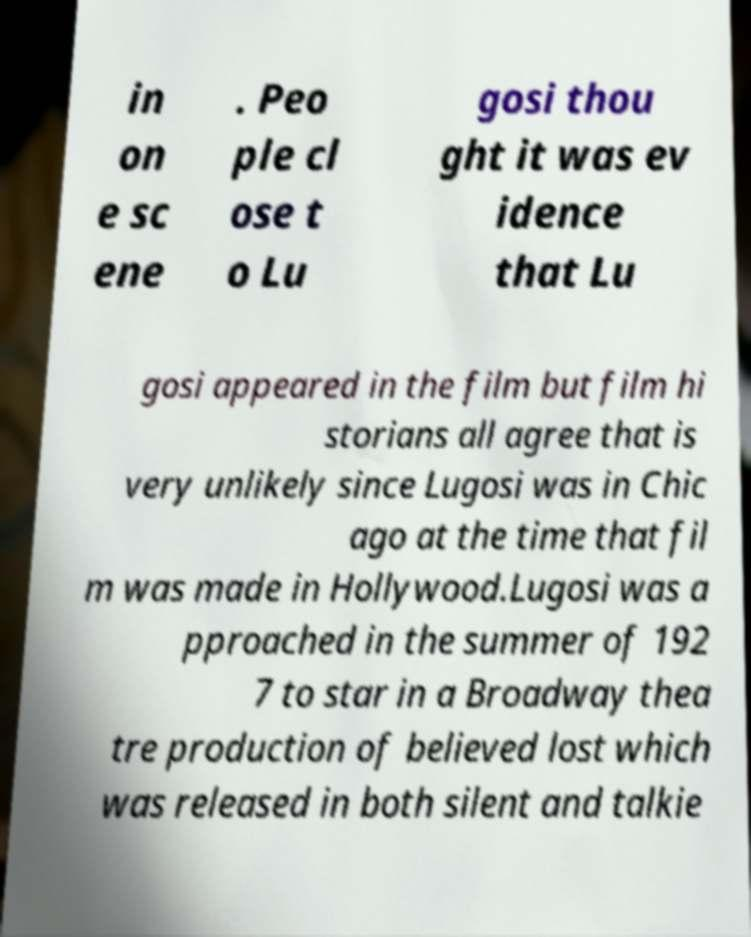Please read and relay the text visible in this image. What does it say? in on e sc ene . Peo ple cl ose t o Lu gosi thou ght it was ev idence that Lu gosi appeared in the film but film hi storians all agree that is very unlikely since Lugosi was in Chic ago at the time that fil m was made in Hollywood.Lugosi was a pproached in the summer of 192 7 to star in a Broadway thea tre production of believed lost which was released in both silent and talkie 